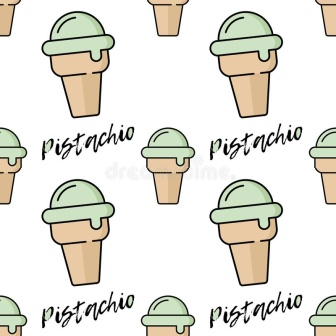Why do you think the word 'Pistachio' is written above and below each cone? The word 'Pistachio' is written above and below each cone to reinforce and highlight the flavor of the ice cream. This repetition ensures that viewers are continuously reminded of the specific type of ice cream being depicted, enhancing the overall theme and cohesion of the image. Additionally, the bold, stylish text adds a visual element that complements the cones and integrates text with the design, making the image more dynamic and engaging. 